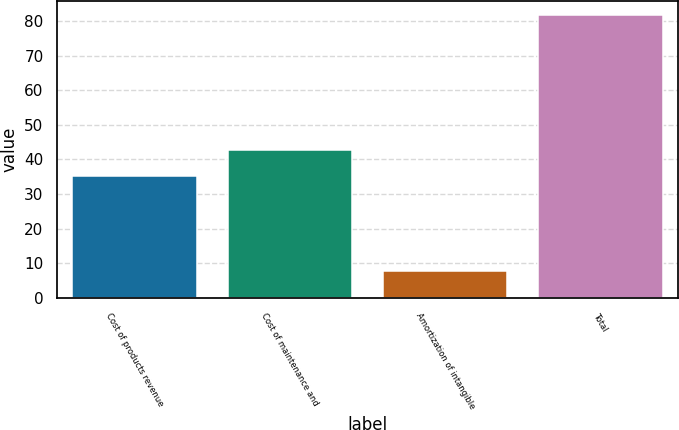Convert chart to OTSL. <chart><loc_0><loc_0><loc_500><loc_500><bar_chart><fcel>Cost of products revenue<fcel>Cost of maintenance and<fcel>Amortization of intangible<fcel>Total<nl><fcel>35.2<fcel>42.58<fcel>7.9<fcel>81.7<nl></chart> 